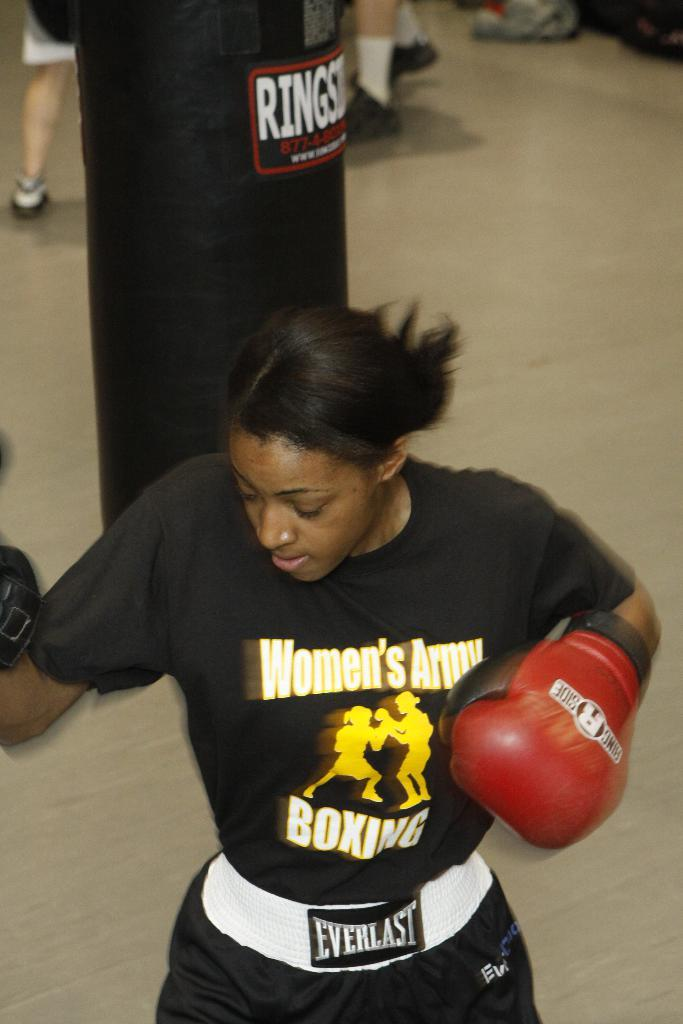<image>
Provide a brief description of the given image. A woman wearing a black Women's Army Boxing shirt training. 